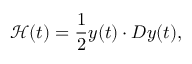<formula> <loc_0><loc_0><loc_500><loc_500>\mathcal { H } ( t ) = \frac { 1 } { 2 } y ( t ) \cdot D y ( t ) ,</formula> 